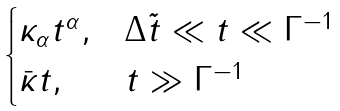Convert formula to latex. <formula><loc_0><loc_0><loc_500><loc_500>\begin{cases} \kappa _ { \alpha } t ^ { \alpha } , & \Delta \tilde { t } \ll t \ll \Gamma ^ { - 1 } \\ \bar { \kappa } t , & t \gg \Gamma ^ { - 1 } \end{cases}</formula> 